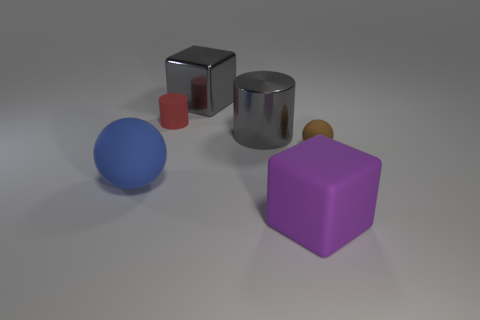There is a purple object that is the same material as the tiny red object; what is its shape?
Provide a succinct answer. Cube. How many other objects are there of the same shape as the purple object?
Ensure brevity in your answer.  1. What number of green objects are either matte blocks or matte spheres?
Your response must be concise. 0. Do the blue rubber object and the small red object have the same shape?
Your response must be concise. No. Is there a big gray cylinder on the left side of the large object to the left of the gray shiny cube?
Offer a terse response. No. Are there an equal number of small balls that are behind the rubber block and large blocks?
Offer a terse response. No. What number of other things are the same size as the gray metallic block?
Give a very brief answer. 3. Does the gray thing behind the red cylinder have the same material as the tiny thing that is left of the tiny brown matte object?
Offer a terse response. No. There is a cube that is behind the sphere in front of the tiny brown thing; how big is it?
Offer a terse response. Large. Is there a tiny object of the same color as the small sphere?
Offer a very short reply. No. 